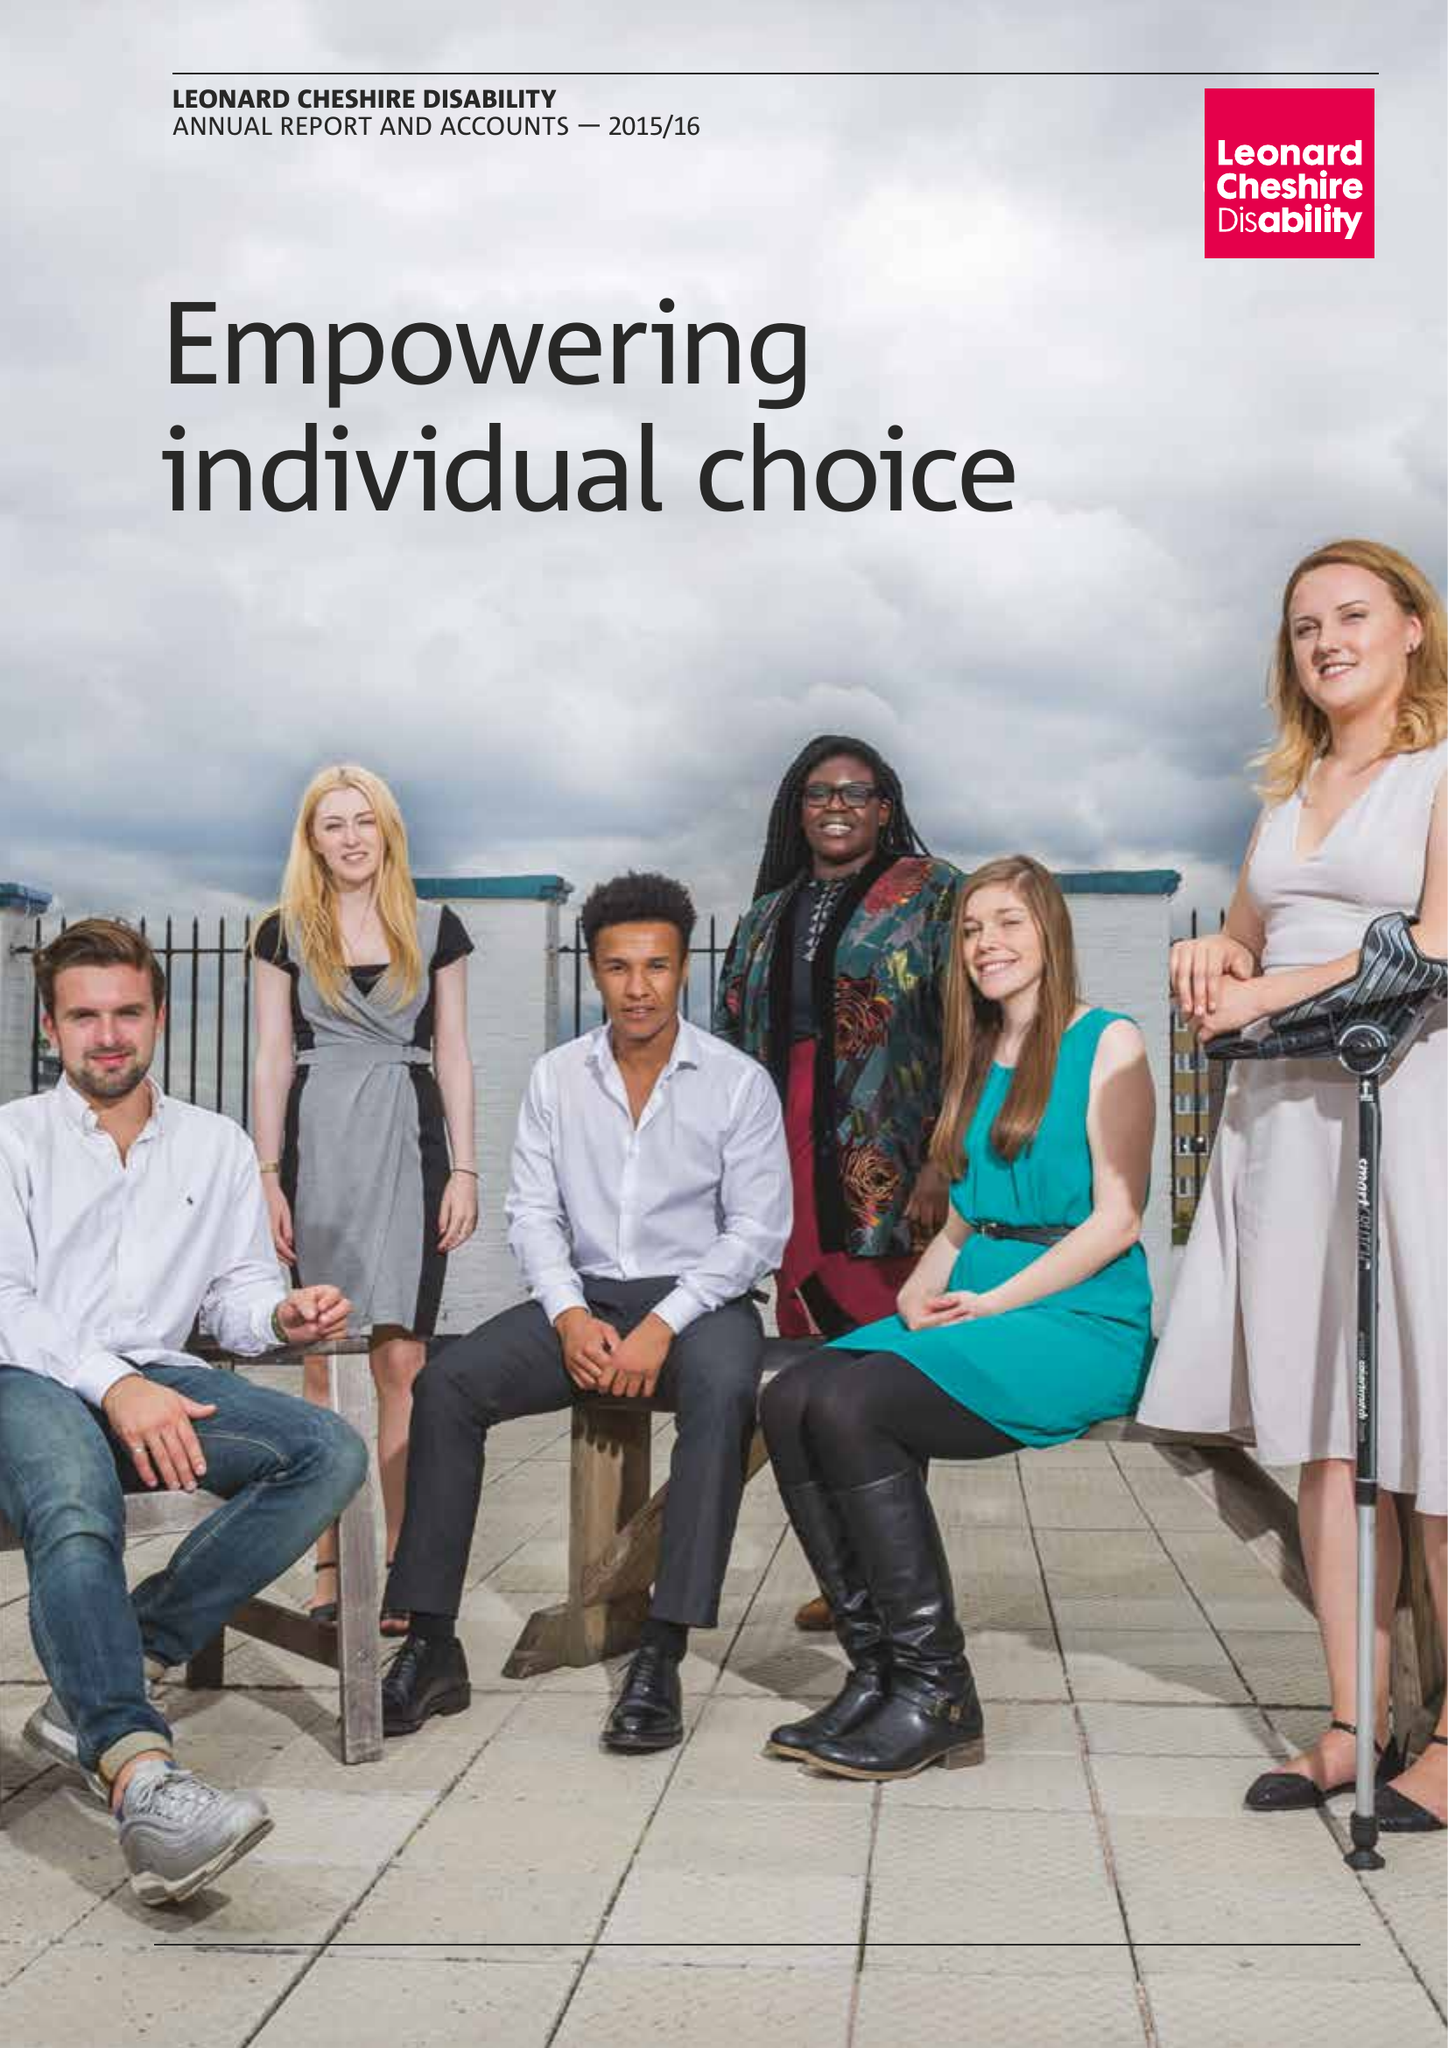What is the value for the spending_annually_in_british_pounds?
Answer the question using a single word or phrase. 156587000.00 